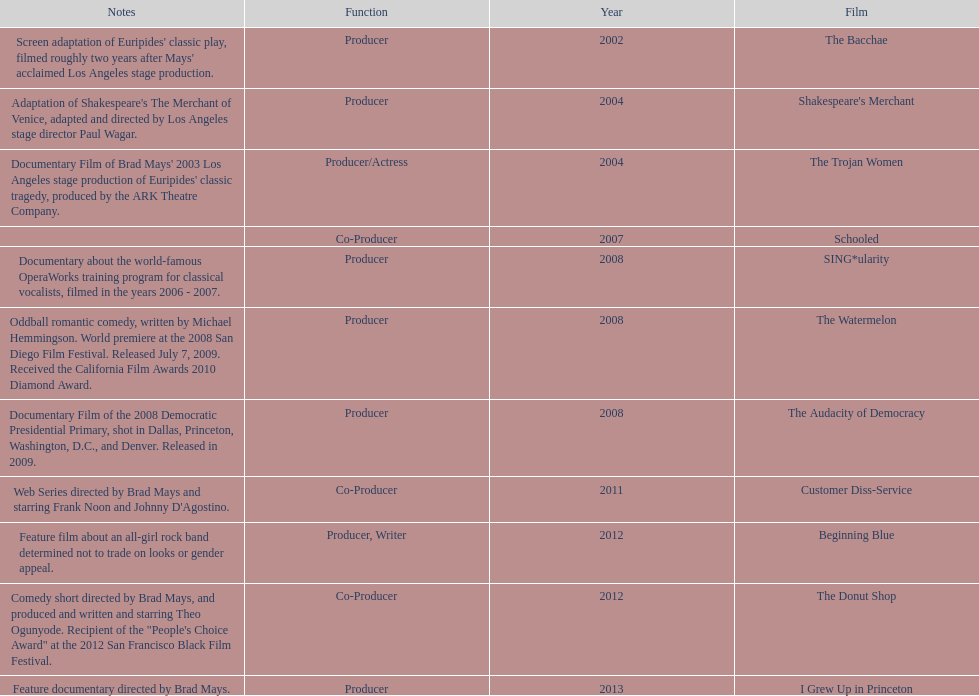How many films did ms. starfelt produce after 2010? 4. 